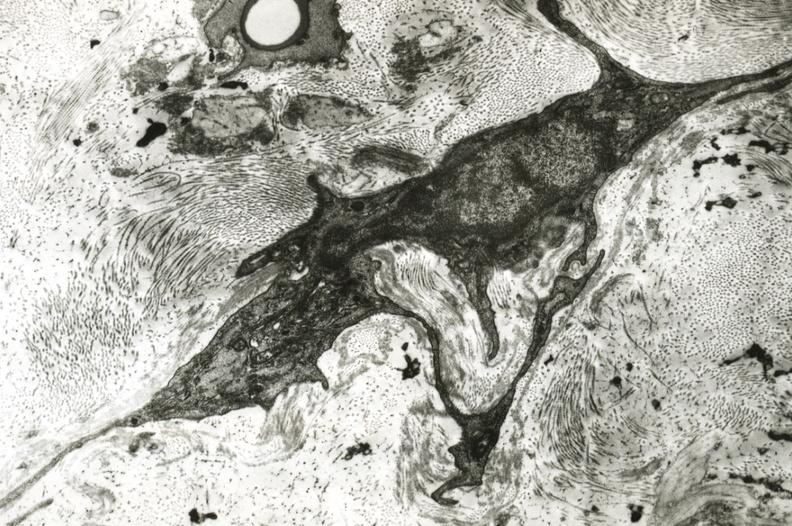what is present?
Answer the question using a single word or phrase. Vasculature 